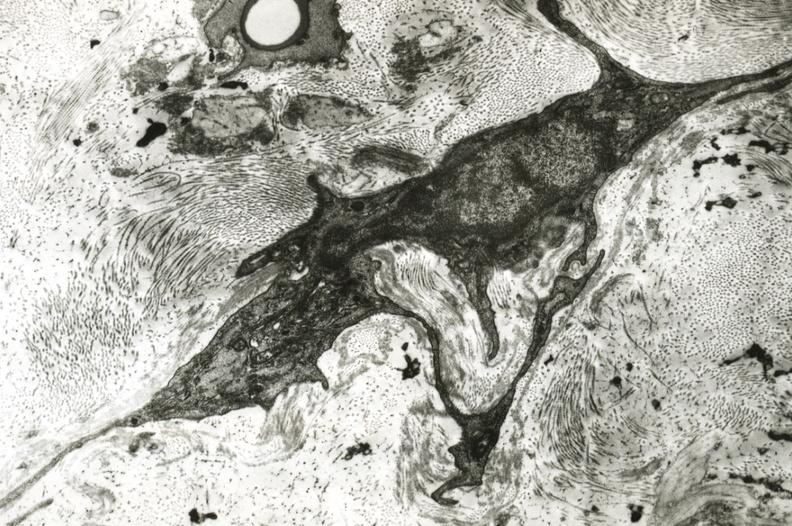what is present?
Answer the question using a single word or phrase. Vasculature 